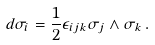<formula> <loc_0><loc_0><loc_500><loc_500>d \sigma _ { i } = \frac { 1 } { 2 } \epsilon _ { i j k } \sigma _ { j } \wedge \sigma _ { k } \, .</formula> 